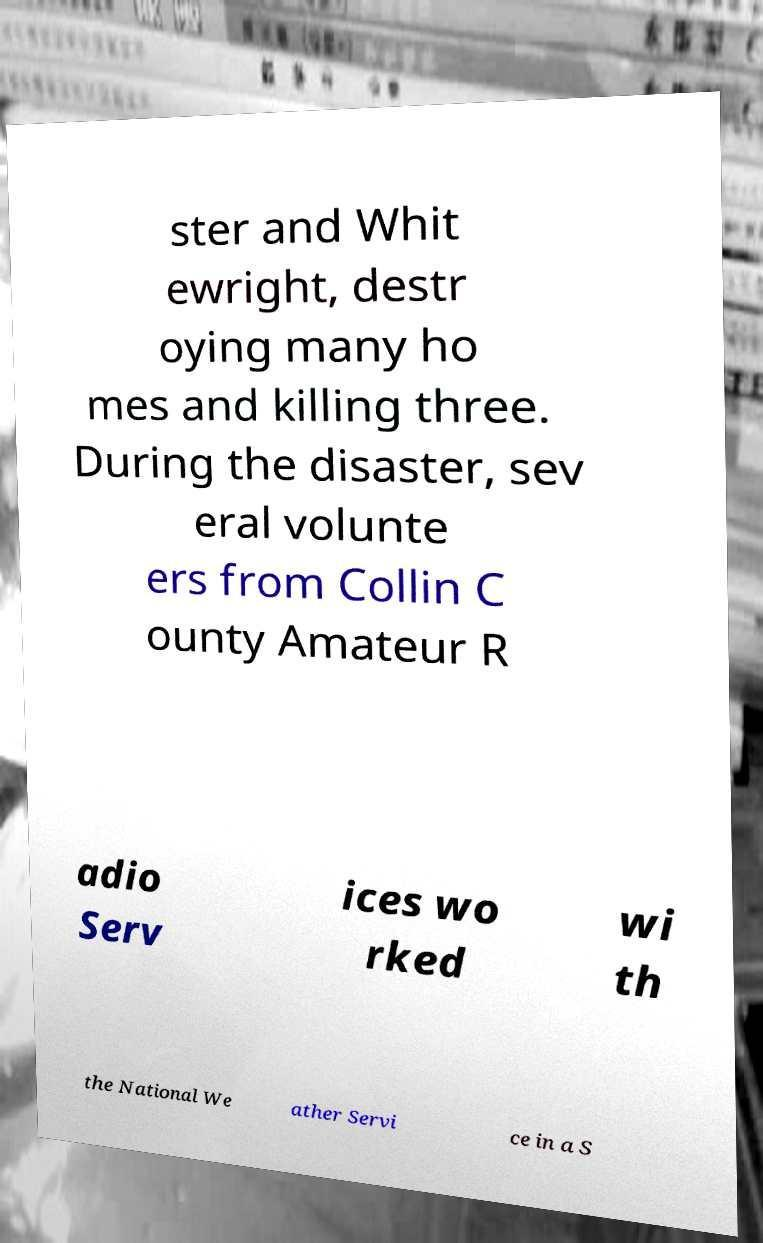What messages or text are displayed in this image? I need them in a readable, typed format. ster and Whit ewright, destr oying many ho mes and killing three. During the disaster, sev eral volunte ers from Collin C ounty Amateur R adio Serv ices wo rked wi th the National We ather Servi ce in a S 